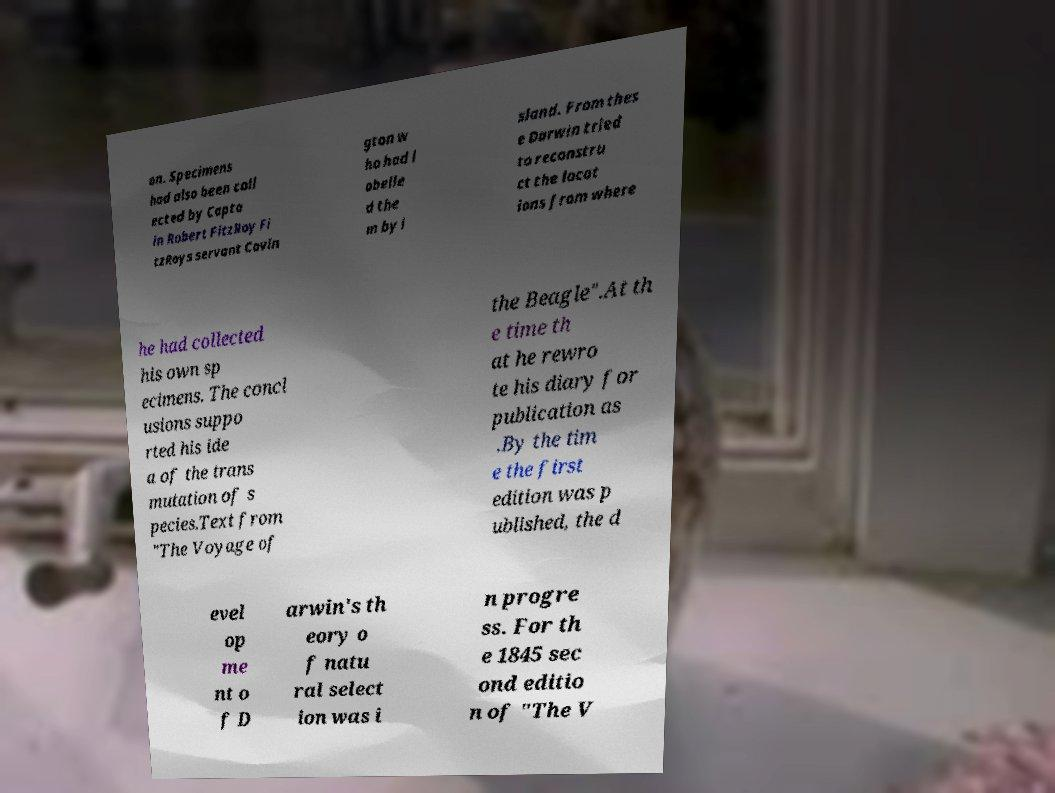Could you extract and type out the text from this image? on. Specimens had also been coll ected by Capta in Robert FitzRoy Fi tzRoys servant Covin gton w ho had l abelle d the m by i sland. From thes e Darwin tried to reconstru ct the locat ions from where he had collected his own sp ecimens. The concl usions suppo rted his ide a of the trans mutation of s pecies.Text from "The Voyage of the Beagle".At th e time th at he rewro te his diary for publication as .By the tim e the first edition was p ublished, the d evel op me nt o f D arwin's th eory o f natu ral select ion was i n progre ss. For th e 1845 sec ond editio n of "The V 